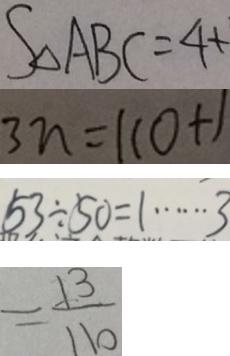Convert formula to latex. <formula><loc_0><loc_0><loc_500><loc_500>S _ { \Delta A B C } = 4 + 
 3 n = 1 1 0 + 1 
 5 3 \div 5 0 = 1 \cdots 3 
 = \frac { 1 3 } { 1 1 0 }</formula> 